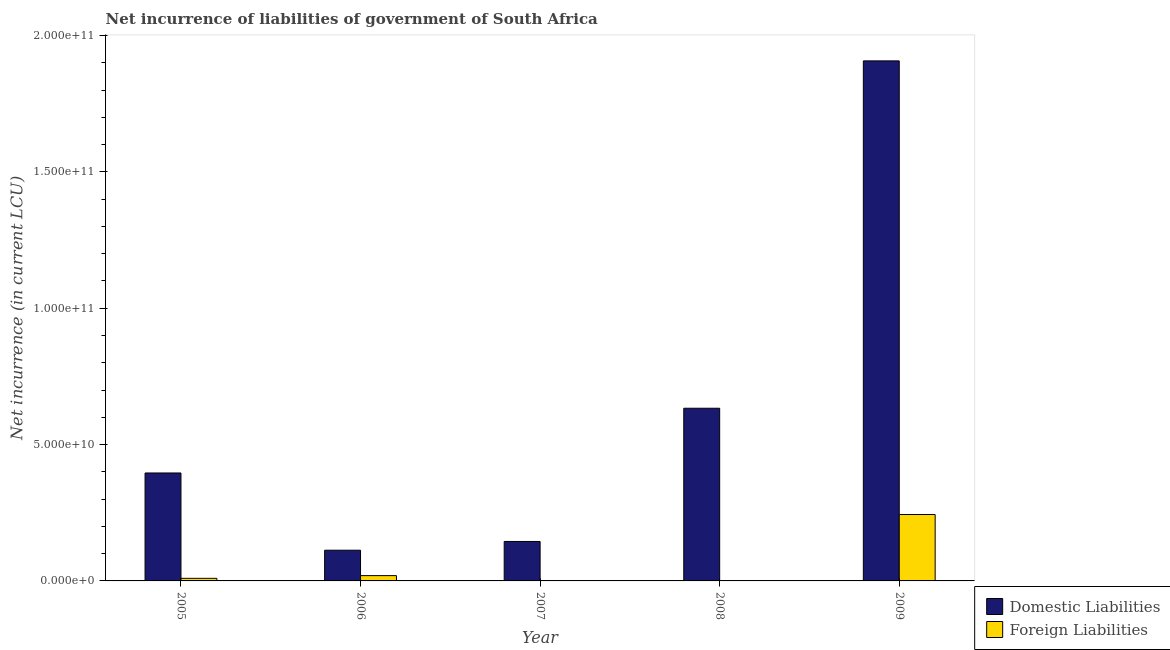Are the number of bars per tick equal to the number of legend labels?
Offer a very short reply. No. Are the number of bars on each tick of the X-axis equal?
Ensure brevity in your answer.  No. What is the label of the 1st group of bars from the left?
Your response must be concise. 2005. Across all years, what is the maximum net incurrence of domestic liabilities?
Make the answer very short. 1.91e+11. Across all years, what is the minimum net incurrence of domestic liabilities?
Offer a very short reply. 1.13e+1. What is the total net incurrence of domestic liabilities in the graph?
Give a very brief answer. 3.19e+11. What is the difference between the net incurrence of domestic liabilities in 2006 and that in 2008?
Ensure brevity in your answer.  -5.21e+1. What is the difference between the net incurrence of foreign liabilities in 2006 and the net incurrence of domestic liabilities in 2008?
Make the answer very short. 1.94e+09. What is the average net incurrence of foreign liabilities per year?
Your response must be concise. 5.45e+09. What is the ratio of the net incurrence of domestic liabilities in 2005 to that in 2007?
Give a very brief answer. 2.73. Is the net incurrence of domestic liabilities in 2006 less than that in 2007?
Your response must be concise. Yes. Is the difference between the net incurrence of foreign liabilities in 2005 and 2006 greater than the difference between the net incurrence of domestic liabilities in 2005 and 2006?
Offer a terse response. No. What is the difference between the highest and the second highest net incurrence of foreign liabilities?
Offer a very short reply. 2.24e+1. What is the difference between the highest and the lowest net incurrence of foreign liabilities?
Your answer should be very brief. 2.44e+1. How many years are there in the graph?
Your answer should be compact. 5. What is the difference between two consecutive major ticks on the Y-axis?
Ensure brevity in your answer.  5.00e+1. Does the graph contain grids?
Provide a succinct answer. No. Where does the legend appear in the graph?
Offer a very short reply. Bottom right. How many legend labels are there?
Your answer should be compact. 2. What is the title of the graph?
Ensure brevity in your answer.  Net incurrence of liabilities of government of South Africa. Does "Exports" appear as one of the legend labels in the graph?
Your response must be concise. No. What is the label or title of the X-axis?
Your response must be concise. Year. What is the label or title of the Y-axis?
Ensure brevity in your answer.  Net incurrence (in current LCU). What is the Net incurrence (in current LCU) in Domestic Liabilities in 2005?
Keep it short and to the point. 3.96e+1. What is the Net incurrence (in current LCU) of Foreign Liabilities in 2005?
Provide a succinct answer. 9.50e+08. What is the Net incurrence (in current LCU) of Domestic Liabilities in 2006?
Your answer should be compact. 1.13e+1. What is the Net incurrence (in current LCU) in Foreign Liabilities in 2006?
Give a very brief answer. 1.94e+09. What is the Net incurrence (in current LCU) in Domestic Liabilities in 2007?
Give a very brief answer. 1.45e+1. What is the Net incurrence (in current LCU) in Foreign Liabilities in 2007?
Your answer should be very brief. 0. What is the Net incurrence (in current LCU) of Domestic Liabilities in 2008?
Give a very brief answer. 6.33e+1. What is the Net incurrence (in current LCU) of Foreign Liabilities in 2008?
Make the answer very short. 0. What is the Net incurrence (in current LCU) in Domestic Liabilities in 2009?
Your answer should be compact. 1.91e+11. What is the Net incurrence (in current LCU) in Foreign Liabilities in 2009?
Your answer should be compact. 2.44e+1. Across all years, what is the maximum Net incurrence (in current LCU) in Domestic Liabilities?
Provide a succinct answer. 1.91e+11. Across all years, what is the maximum Net incurrence (in current LCU) in Foreign Liabilities?
Your answer should be compact. 2.44e+1. Across all years, what is the minimum Net incurrence (in current LCU) of Domestic Liabilities?
Offer a very short reply. 1.13e+1. What is the total Net incurrence (in current LCU) of Domestic Liabilities in the graph?
Ensure brevity in your answer.  3.19e+11. What is the total Net incurrence (in current LCU) in Foreign Liabilities in the graph?
Ensure brevity in your answer.  2.72e+1. What is the difference between the Net incurrence (in current LCU) in Domestic Liabilities in 2005 and that in 2006?
Your answer should be compact. 2.83e+1. What is the difference between the Net incurrence (in current LCU) in Foreign Liabilities in 2005 and that in 2006?
Your answer should be very brief. -9.93e+08. What is the difference between the Net incurrence (in current LCU) of Domestic Liabilities in 2005 and that in 2007?
Offer a very short reply. 2.51e+1. What is the difference between the Net incurrence (in current LCU) in Domestic Liabilities in 2005 and that in 2008?
Provide a short and direct response. -2.37e+1. What is the difference between the Net incurrence (in current LCU) in Domestic Liabilities in 2005 and that in 2009?
Provide a short and direct response. -1.51e+11. What is the difference between the Net incurrence (in current LCU) of Foreign Liabilities in 2005 and that in 2009?
Your answer should be very brief. -2.34e+1. What is the difference between the Net incurrence (in current LCU) in Domestic Liabilities in 2006 and that in 2007?
Your answer should be very brief. -3.21e+09. What is the difference between the Net incurrence (in current LCU) of Domestic Liabilities in 2006 and that in 2008?
Offer a very short reply. -5.21e+1. What is the difference between the Net incurrence (in current LCU) of Domestic Liabilities in 2006 and that in 2009?
Keep it short and to the point. -1.79e+11. What is the difference between the Net incurrence (in current LCU) of Foreign Liabilities in 2006 and that in 2009?
Provide a succinct answer. -2.24e+1. What is the difference between the Net incurrence (in current LCU) in Domestic Liabilities in 2007 and that in 2008?
Offer a very short reply. -4.89e+1. What is the difference between the Net incurrence (in current LCU) in Domestic Liabilities in 2007 and that in 2009?
Offer a terse response. -1.76e+11. What is the difference between the Net incurrence (in current LCU) of Domestic Liabilities in 2008 and that in 2009?
Your response must be concise. -1.27e+11. What is the difference between the Net incurrence (in current LCU) of Domestic Liabilities in 2005 and the Net incurrence (in current LCU) of Foreign Liabilities in 2006?
Provide a short and direct response. 3.76e+1. What is the difference between the Net incurrence (in current LCU) of Domestic Liabilities in 2005 and the Net incurrence (in current LCU) of Foreign Liabilities in 2009?
Provide a succinct answer. 1.52e+1. What is the difference between the Net incurrence (in current LCU) of Domestic Liabilities in 2006 and the Net incurrence (in current LCU) of Foreign Liabilities in 2009?
Provide a short and direct response. -1.31e+1. What is the difference between the Net incurrence (in current LCU) of Domestic Liabilities in 2007 and the Net incurrence (in current LCU) of Foreign Liabilities in 2009?
Ensure brevity in your answer.  -9.88e+09. What is the difference between the Net incurrence (in current LCU) of Domestic Liabilities in 2008 and the Net incurrence (in current LCU) of Foreign Liabilities in 2009?
Provide a short and direct response. 3.90e+1. What is the average Net incurrence (in current LCU) of Domestic Liabilities per year?
Provide a short and direct response. 6.39e+1. What is the average Net incurrence (in current LCU) in Foreign Liabilities per year?
Offer a terse response. 5.45e+09. In the year 2005, what is the difference between the Net incurrence (in current LCU) of Domestic Liabilities and Net incurrence (in current LCU) of Foreign Liabilities?
Your answer should be very brief. 3.86e+1. In the year 2006, what is the difference between the Net incurrence (in current LCU) of Domestic Liabilities and Net incurrence (in current LCU) of Foreign Liabilities?
Provide a short and direct response. 9.32e+09. In the year 2009, what is the difference between the Net incurrence (in current LCU) in Domestic Liabilities and Net incurrence (in current LCU) in Foreign Liabilities?
Your response must be concise. 1.66e+11. What is the ratio of the Net incurrence (in current LCU) in Domestic Liabilities in 2005 to that in 2006?
Provide a short and direct response. 3.52. What is the ratio of the Net incurrence (in current LCU) of Foreign Liabilities in 2005 to that in 2006?
Provide a short and direct response. 0.49. What is the ratio of the Net incurrence (in current LCU) of Domestic Liabilities in 2005 to that in 2007?
Offer a very short reply. 2.73. What is the ratio of the Net incurrence (in current LCU) in Domestic Liabilities in 2005 to that in 2008?
Provide a short and direct response. 0.63. What is the ratio of the Net incurrence (in current LCU) in Domestic Liabilities in 2005 to that in 2009?
Your answer should be compact. 0.21. What is the ratio of the Net incurrence (in current LCU) of Foreign Liabilities in 2005 to that in 2009?
Keep it short and to the point. 0.04. What is the ratio of the Net incurrence (in current LCU) in Domestic Liabilities in 2006 to that in 2007?
Your answer should be compact. 0.78. What is the ratio of the Net incurrence (in current LCU) in Domestic Liabilities in 2006 to that in 2008?
Your answer should be very brief. 0.18. What is the ratio of the Net incurrence (in current LCU) of Domestic Liabilities in 2006 to that in 2009?
Provide a short and direct response. 0.06. What is the ratio of the Net incurrence (in current LCU) in Foreign Liabilities in 2006 to that in 2009?
Your answer should be compact. 0.08. What is the ratio of the Net incurrence (in current LCU) of Domestic Liabilities in 2007 to that in 2008?
Provide a short and direct response. 0.23. What is the ratio of the Net incurrence (in current LCU) of Domestic Liabilities in 2007 to that in 2009?
Offer a very short reply. 0.08. What is the ratio of the Net incurrence (in current LCU) of Domestic Liabilities in 2008 to that in 2009?
Your answer should be very brief. 0.33. What is the difference between the highest and the second highest Net incurrence (in current LCU) of Domestic Liabilities?
Your answer should be very brief. 1.27e+11. What is the difference between the highest and the second highest Net incurrence (in current LCU) in Foreign Liabilities?
Make the answer very short. 2.24e+1. What is the difference between the highest and the lowest Net incurrence (in current LCU) in Domestic Liabilities?
Provide a short and direct response. 1.79e+11. What is the difference between the highest and the lowest Net incurrence (in current LCU) in Foreign Liabilities?
Provide a short and direct response. 2.44e+1. 